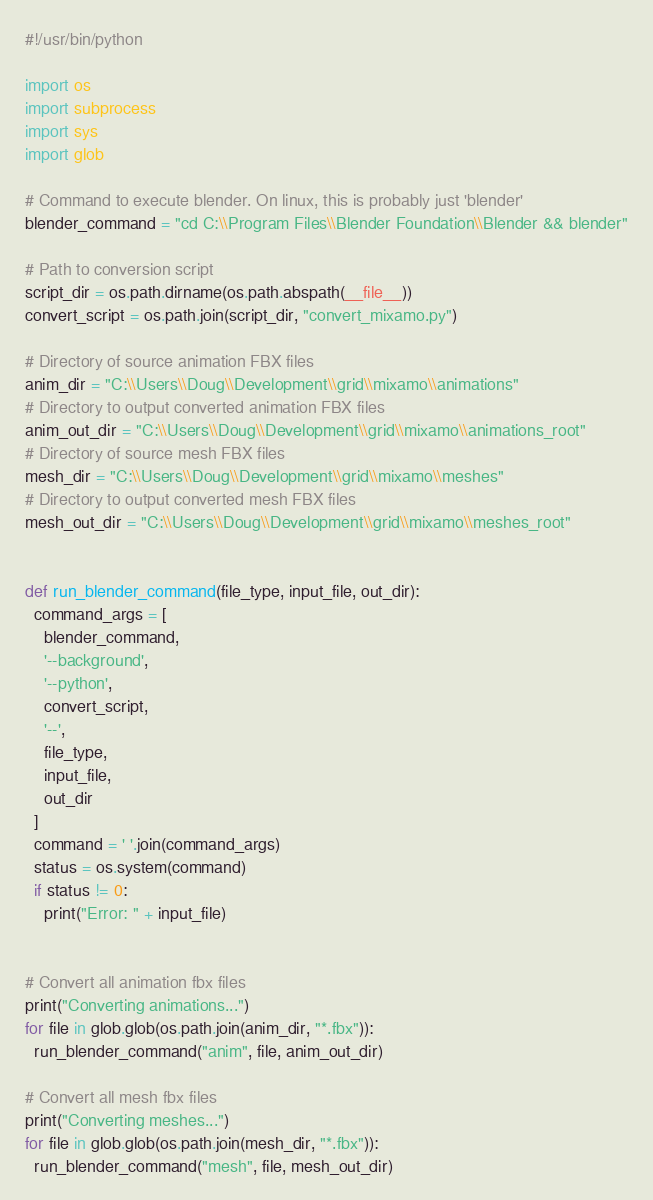Convert code to text. <code><loc_0><loc_0><loc_500><loc_500><_Python_>#!/usr/bin/python

import os
import subprocess
import sys
import glob

# Command to execute blender. On linux, this is probably just 'blender'
blender_command = "cd C:\\Program Files\\Blender Foundation\\Blender && blender"

# Path to conversion script
script_dir = os.path.dirname(os.path.abspath(__file__))
convert_script = os.path.join(script_dir, "convert_mixamo.py")

# Directory of source animation FBX files
anim_dir = "C:\\Users\\Doug\\Development\\grid\\mixamo\\animations"
# Directory to output converted animation FBX files
anim_out_dir = "C:\\Users\\Doug\\Development\\grid\\mixamo\\animations_root"
# Directory of source mesh FBX files
mesh_dir = "C:\\Users\\Doug\\Development\\grid\\mixamo\\meshes"
# Directory to output converted mesh FBX files
mesh_out_dir = "C:\\Users\\Doug\\Development\\grid\\mixamo\\meshes_root"


def run_blender_command(file_type, input_file, out_dir):
  command_args = [
    blender_command,
    '--background',
    '--python',
    convert_script,
    '--',
    file_type,
    input_file,
    out_dir
  ]
  command = ' '.join(command_args)
  status = os.system(command)
  if status != 0:
    print("Error: " + input_file)


# Convert all animation fbx files
print("Converting animations...")
for file in glob.glob(os.path.join(anim_dir, "*.fbx")):
  run_blender_command("anim", file, anim_out_dir)

# Convert all mesh fbx files
print("Converting meshes...")
for file in glob.glob(os.path.join(mesh_dir, "*.fbx")):
  run_blender_command("mesh", file, mesh_out_dir)
</code> 